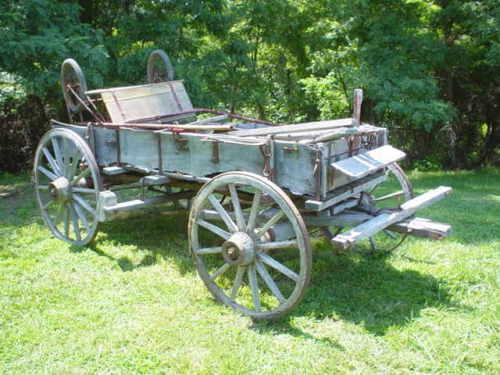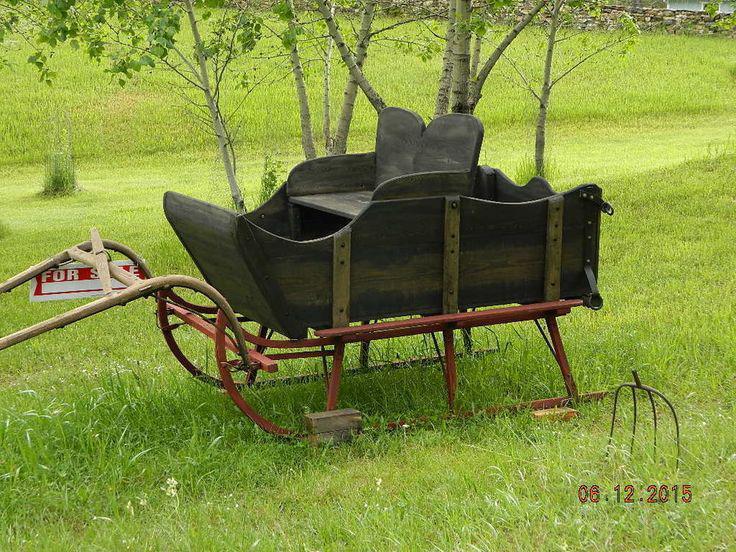The first image is the image on the left, the second image is the image on the right. Assess this claim about the two images: "There is a two wheel cart in at least one of the images.". Correct or not? Answer yes or no. No. The first image is the image on the left, the second image is the image on the right. Given the left and right images, does the statement "At least one image shows a two-wheeled cart with no passengers, parked on green grass." hold true? Answer yes or no. No. 